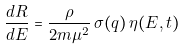<formula> <loc_0><loc_0><loc_500><loc_500>\frac { d R } { d E } = \frac { \rho } { 2 m \mu ^ { 2 } } \, \sigma ( q ) \, \eta ( E , t )</formula> 